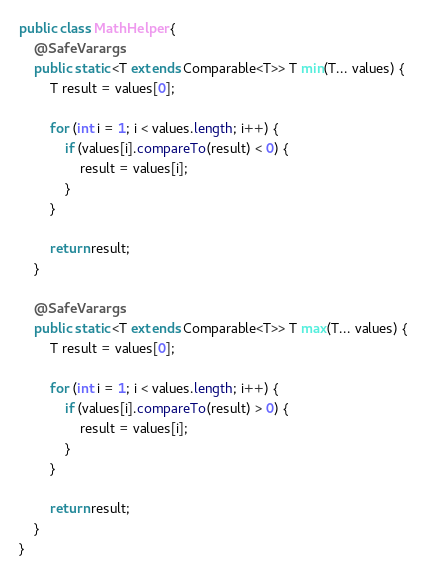<code> <loc_0><loc_0><loc_500><loc_500><_Java_>
public class MathHelper {
    @SafeVarargs
    public static <T extends Comparable<T>> T min(T... values) {
        T result = values[0];

        for (int i = 1; i < values.length; i++) {
            if (values[i].compareTo(result) < 0) {
                result = values[i];
            }
        }

        return result;
    }

    @SafeVarargs
    public static <T extends Comparable<T>> T max(T... values) {
        T result = values[0];

        for (int i = 1; i < values.length; i++) {
            if (values[i].compareTo(result) > 0) {
                result = values[i];
            }
        }

        return result;
    }
}
</code> 